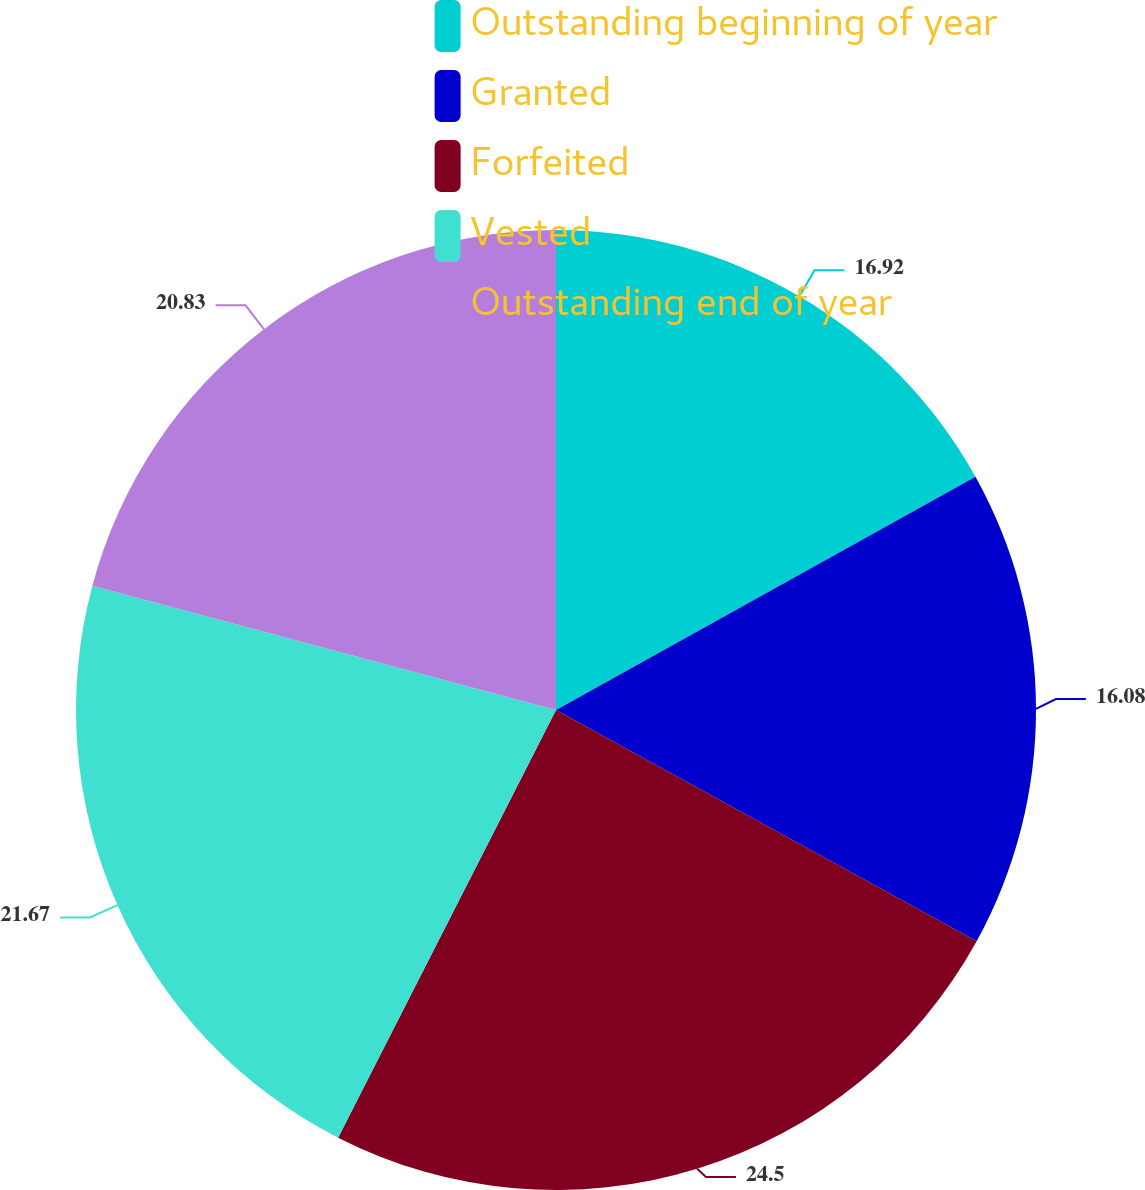Convert chart to OTSL. <chart><loc_0><loc_0><loc_500><loc_500><pie_chart><fcel>Outstanding beginning of year<fcel>Granted<fcel>Forfeited<fcel>Vested<fcel>Outstanding end of year<nl><fcel>16.92%<fcel>16.08%<fcel>24.5%<fcel>21.67%<fcel>20.83%<nl></chart> 